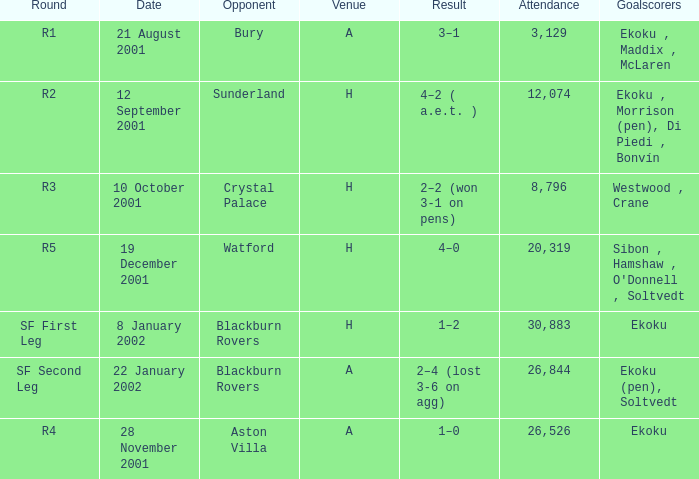Which venue has attendance larger than 26,526, and sf first leg round? H. 